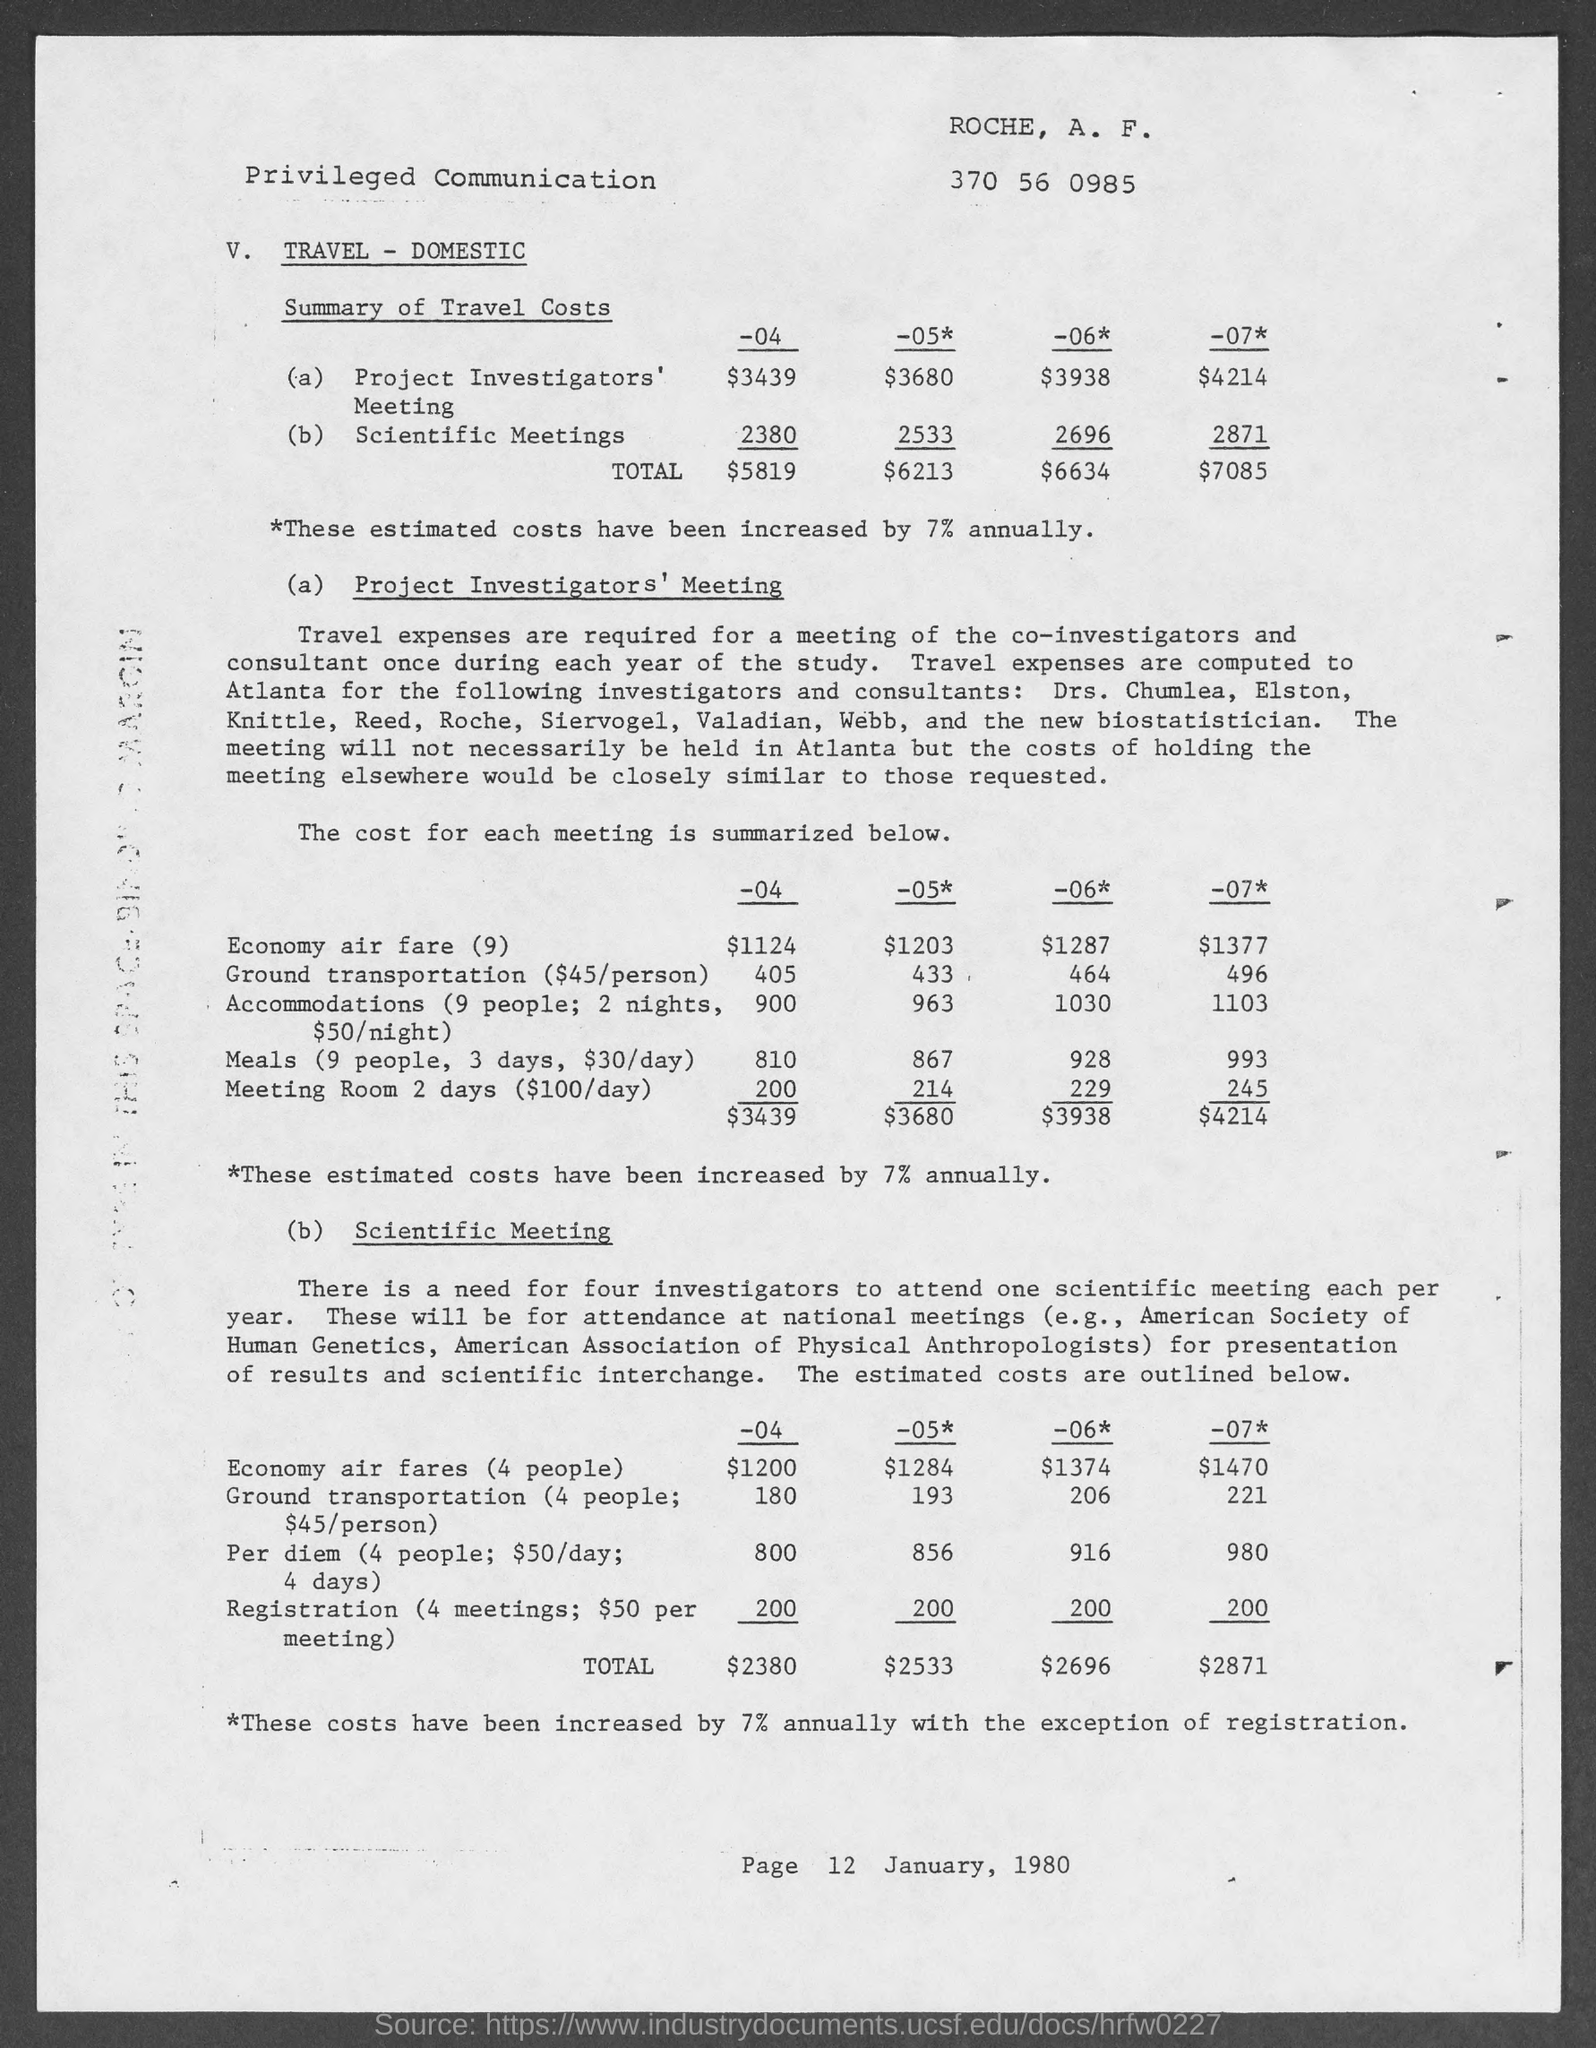What is the travel cost for 'Project Investigator's Meeting' for the year '-04' ?
Your response must be concise. $3439. What is the travel cost for 'Scientific Meetings' for the year '-07' ?
Your response must be concise. 2871. What is the total travel cost for the year '-05' ?
Offer a very short reply. $6213. 